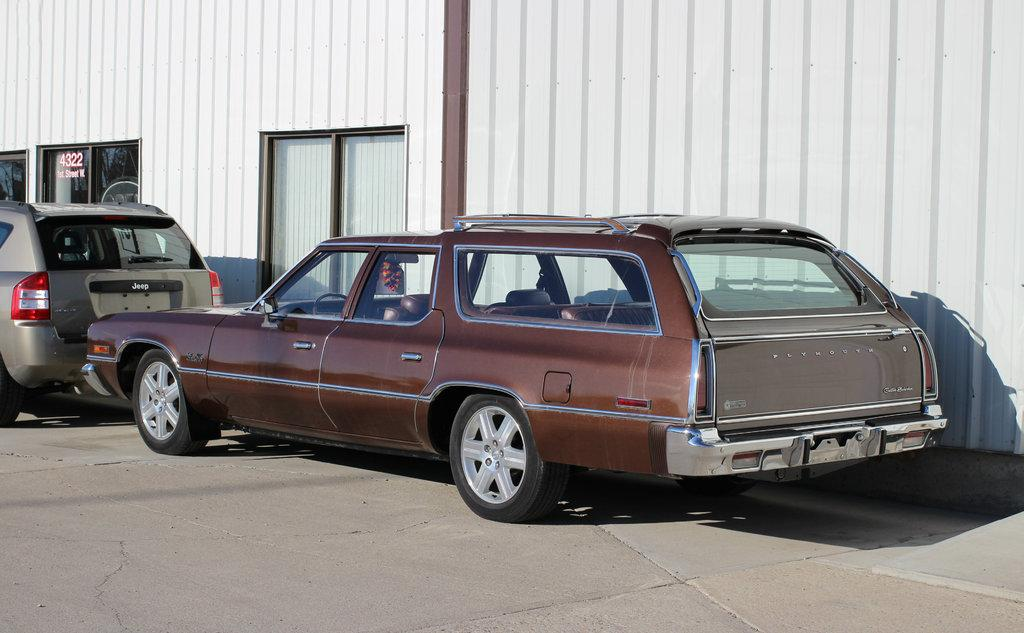Where was the picture taken? The picture was clicked outside. What can be seen in the center of the image? There are cars parked on the ground in the center of the image. What type of objects are present in the background of the image? There are metal objects in the background of the image. What else can be seen in the background of the image? There are windows visible in the background of the image. What type of lettuce is growing in the mouth of the person in the image? There is no person or lettuce present in the image. 